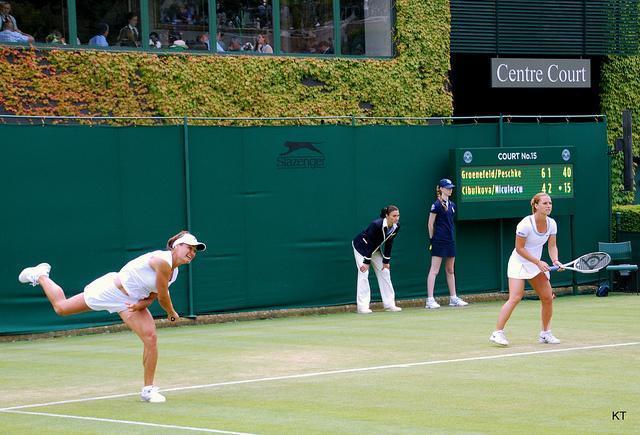How many people are in the picture?
Give a very brief answer. 5. How many of the train cars are yellow and red?
Give a very brief answer. 0. 